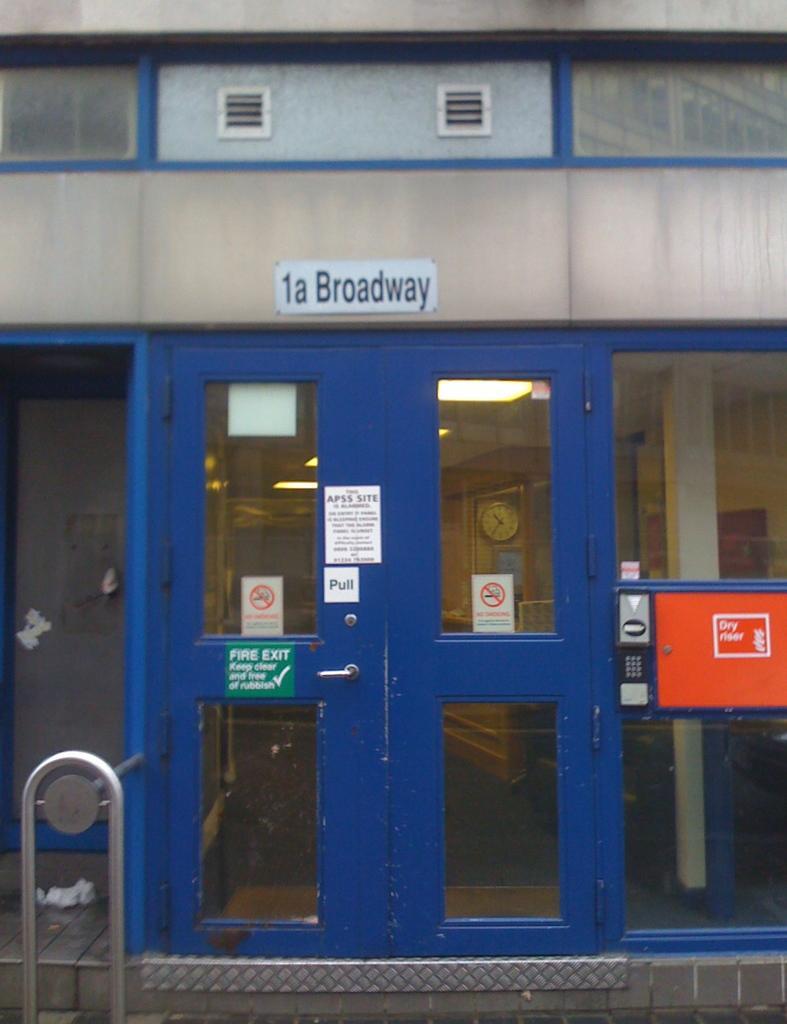Could you give a brief overview of what you see in this image? In this picture we can see boards, door, handle and stand. Through glass inside view is visible. We can see the lights and the clock. On the right side of the picture it seems like a device with the keys. 